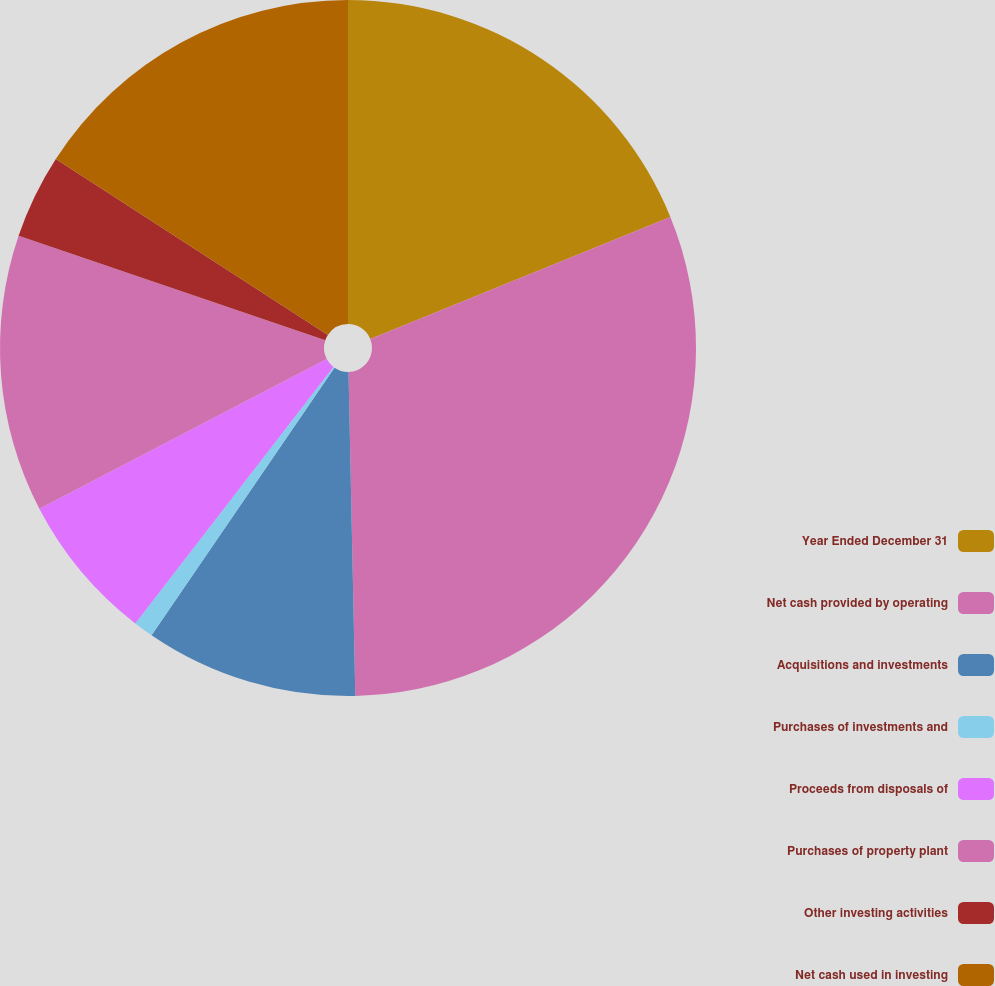Convert chart to OTSL. <chart><loc_0><loc_0><loc_500><loc_500><pie_chart><fcel>Year Ended December 31<fcel>Net cash provided by operating<fcel>Acquisitions and investments<fcel>Purchases of investments and<fcel>Proceeds from disposals of<fcel>Purchases of property plant<fcel>Other investing activities<fcel>Net cash used in investing<nl><fcel>18.85%<fcel>30.81%<fcel>9.88%<fcel>0.92%<fcel>6.89%<fcel>12.87%<fcel>3.91%<fcel>15.86%<nl></chart> 